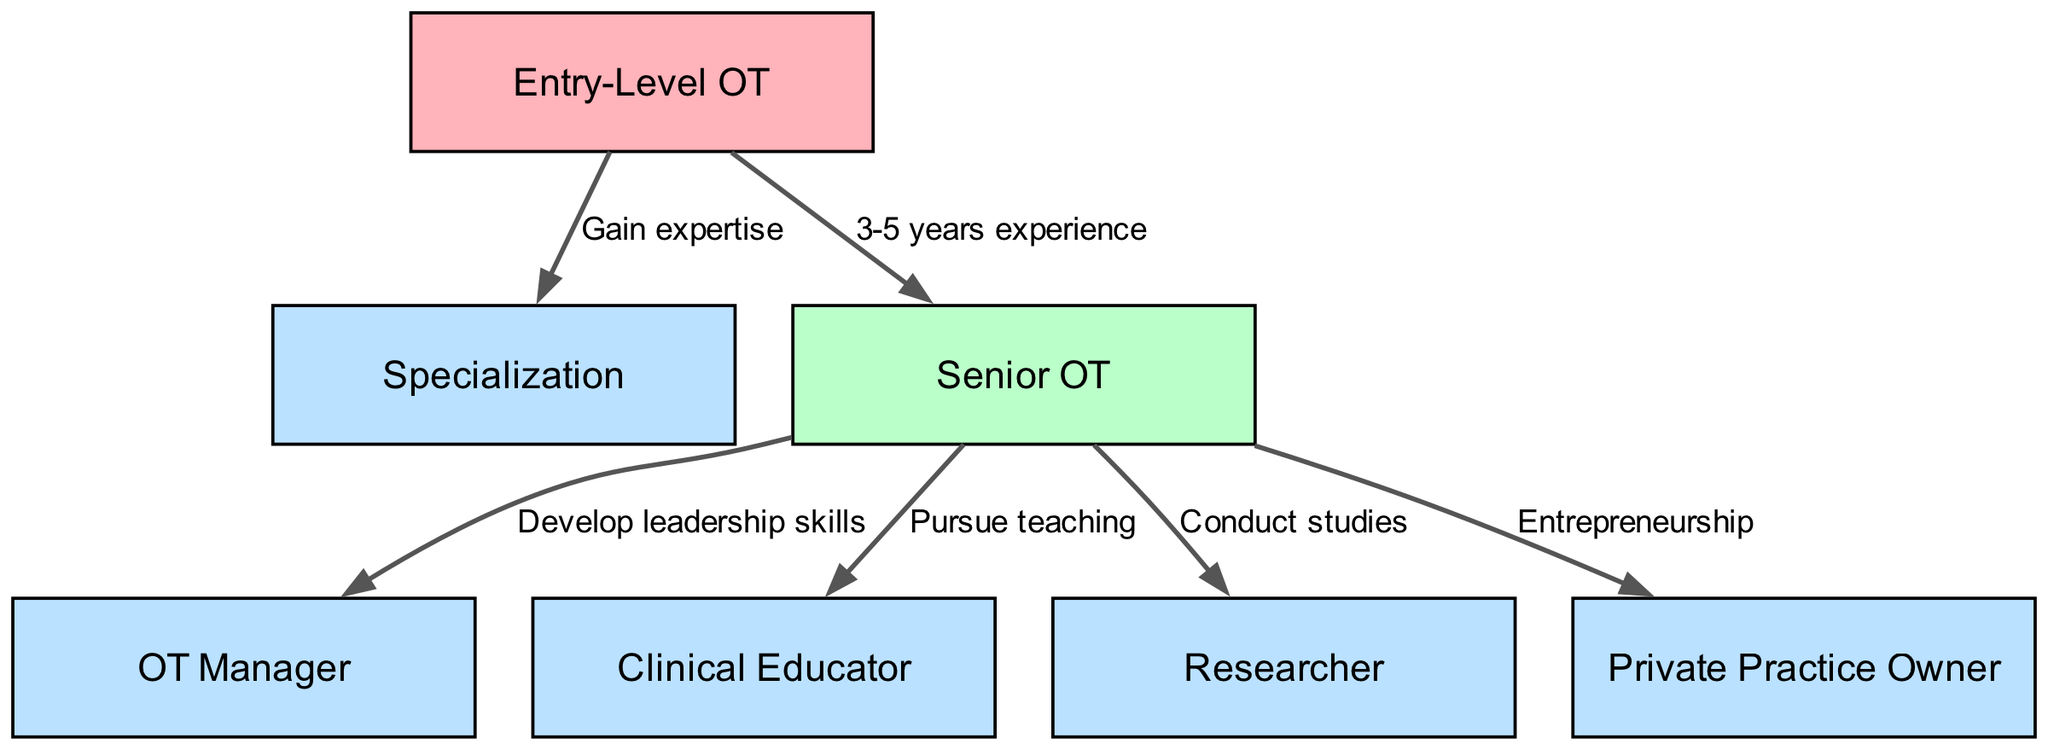What is the starting point in the career progression for occupational therapists? The diagram clearly identifies "Entry-Level OT" as the starting point for the career progression pathway. This can be found at the top of the diagram.
Answer: Entry-Level OT How many different career options are available after being a Senior OT? There are five career options available after progressing from a Senior OT, as indicated by the five edges leading from "Senior OT" to its connected nodes in the diagram: OT Manager, Clinical Educator, Researcher, Private Practice Owner, and an option for Specialization as well.
Answer: 5 What is the label that describes moving from Entry-Level OT to Senior OT? The diagram specifies "3-5 years experience" as the label for the edge connecting "Entry-Level OT" and "Senior OT", which denotes what is needed to transition to that position.
Answer: 3-5 years experience Which role is directly connected to gaining expertise? The "Specialization" node is directly connected to the "Entry-Level OT" node and is labeled as "Gain expertise," indicating that this is the role involved in that transition.
Answer: Specialization What step is required to move from Senior OT to OT Manager? The transition from "Senior OT" to "OT Manager" is labeled "Develop leadership skills," which defines the necessary step to pursue this career advancement.
Answer: Develop leadership skills What career path follows the pursuit of teaching after becoming a Senior OT? After pursuing teaching, the next career path that follows is "Clinical Educator," as indicated by the edge leading from "Senior OT" to that node.
Answer: Clinical Educator What is one career option for a Senior OT that involves entrepreneurship? The node representing "Private Practice Owner" is specifically linked to "Senior OT" with the label "Entrepreneurship," highlighting this career path as an entrepreneurial option.
Answer: Private Practice Owner How many nodes are represented in the diagram? The diagram includes a total of 6 nodes: Entry-Level OT, Specialization, Senior OT, OT Manager, Clinical Educator, Researcher, and Private Practice Owner, resulting in a count of 6.
Answer: 6 